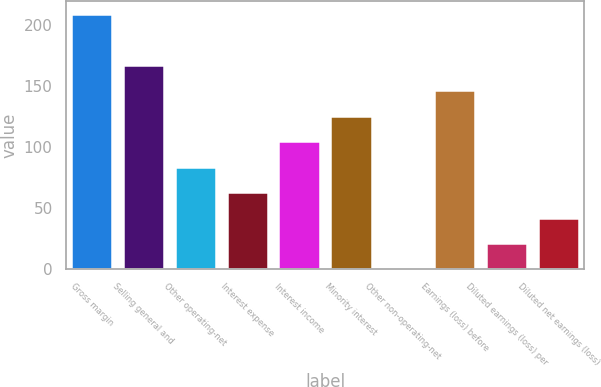Convert chart to OTSL. <chart><loc_0><loc_0><loc_500><loc_500><bar_chart><fcel>Gross margin<fcel>Selling general and<fcel>Other operating-net<fcel>Interest expense<fcel>Interest income<fcel>Minority interest<fcel>Other non-operating-net<fcel>Earnings (loss) before<fcel>Diluted earnings (loss) per<fcel>Diluted net earnings (loss)<nl><fcel>209.2<fcel>167.38<fcel>83.74<fcel>62.83<fcel>104.65<fcel>125.56<fcel>0.1<fcel>146.47<fcel>21.01<fcel>41.92<nl></chart> 